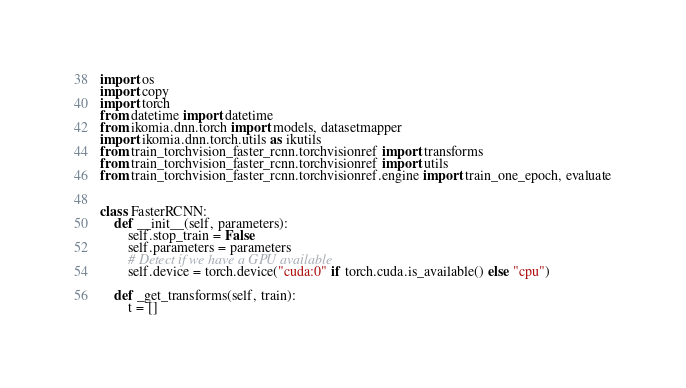<code> <loc_0><loc_0><loc_500><loc_500><_Python_>import os
import copy
import torch
from datetime import datetime
from ikomia.dnn.torch import models, datasetmapper
import ikomia.dnn.torch.utils as ikutils
from train_torchvision_faster_rcnn.torchvisionref import transforms
from train_torchvision_faster_rcnn.torchvisionref import utils
from train_torchvision_faster_rcnn.torchvisionref.engine import train_one_epoch, evaluate


class FasterRCNN:
    def __init__(self, parameters):
        self.stop_train = False
        self.parameters = parameters
        # Detect if we have a GPU available
        self.device = torch.device("cuda:0" if torch.cuda.is_available() else "cpu")

    def _get_transforms(self, train):
        t = []</code> 